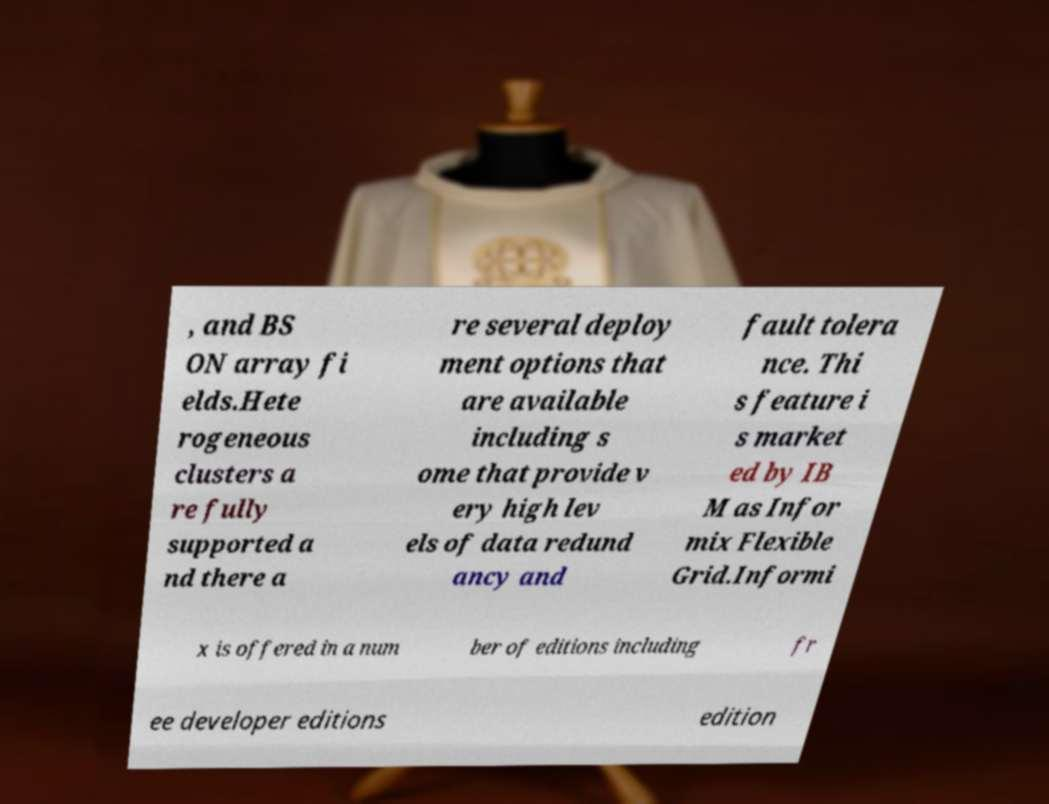Can you read and provide the text displayed in the image?This photo seems to have some interesting text. Can you extract and type it out for me? , and BS ON array fi elds.Hete rogeneous clusters a re fully supported a nd there a re several deploy ment options that are available including s ome that provide v ery high lev els of data redund ancy and fault tolera nce. Thi s feature i s market ed by IB M as Infor mix Flexible Grid.Informi x is offered in a num ber of editions including fr ee developer editions edition 